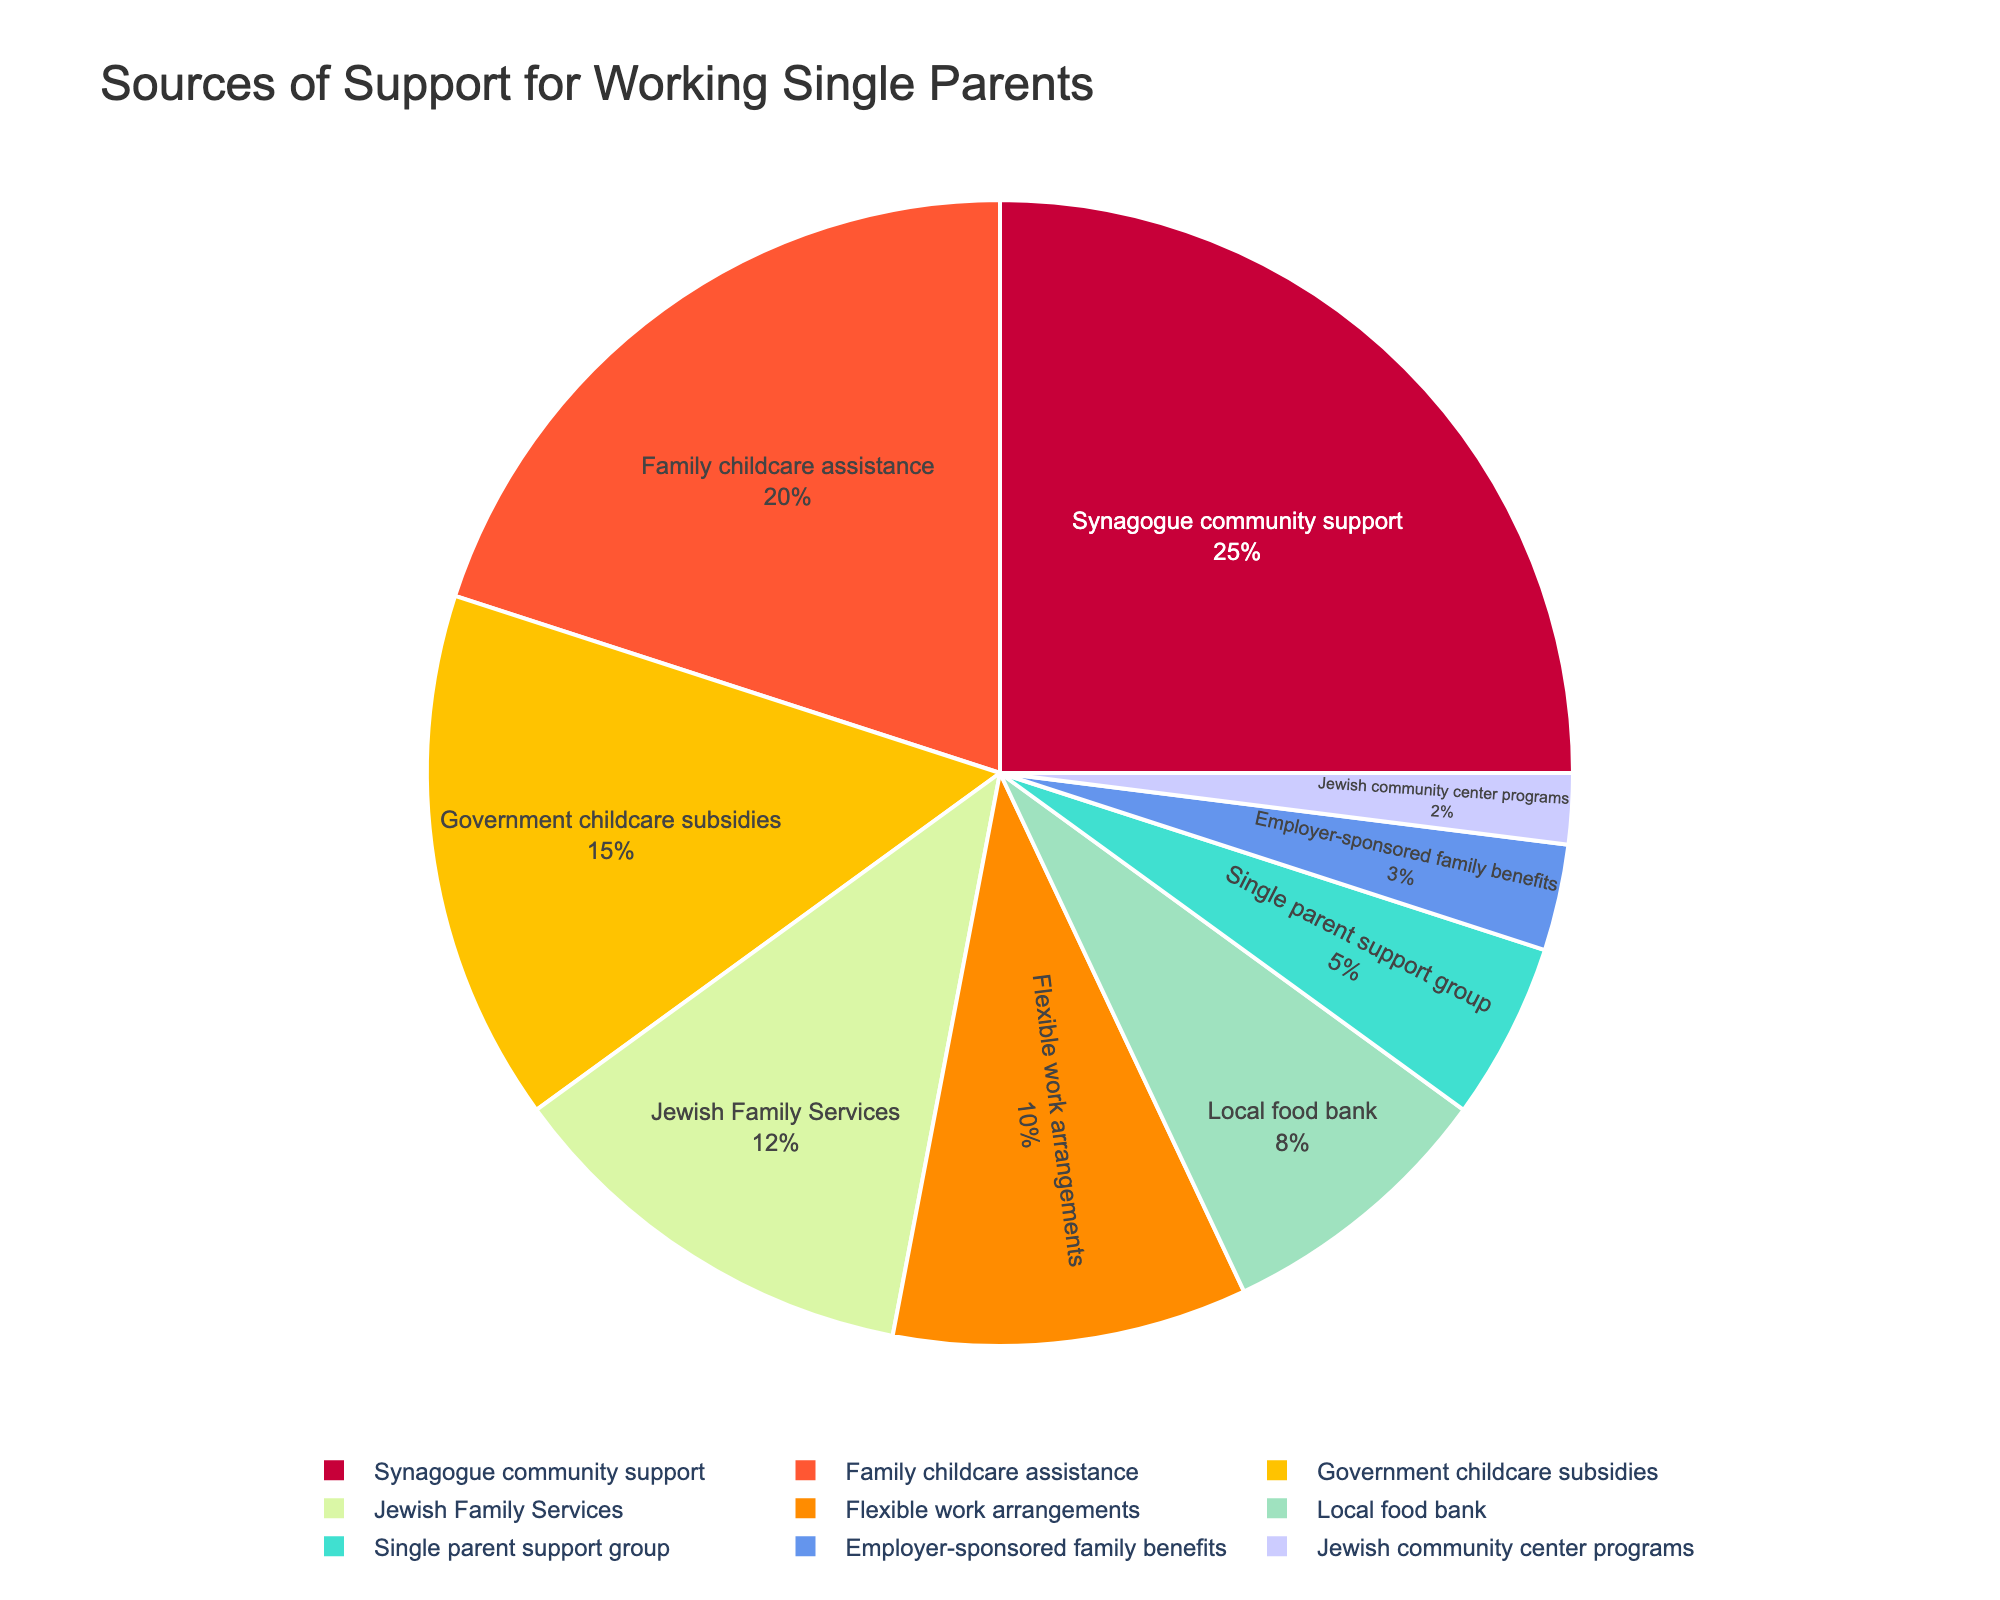Which source of support constitutes the largest portion of the pie chart? The largest portion can be identified by looking for the largest slice of the pie. Synagogue community support occupies the largest slice.
Answer: Synagogue community support What is the combined percentage of Family childcare assistance and Government childcare subsidies? To find the combined percentage, add the percentages of Family childcare assistance (20%) and Government childcare subsidies (15%). 20% + 15% = 35%.
Answer: 35% Which sources of support have a percentage that is less than 10%? To find this, identify all slices in the pie chart with percentages less than 10%. They are Local food bank (8%), Single parent support group (5%), Employer-sponsored family benefits (3%), and Jewish community center programs (2%).
Answer: Local food bank, Single parent support group, Employer-sponsored family benefits, Jewish community center programs By how much does the percentage of Synagogue community support exceed that of Jewish Family Services? Subtract the percentage of Jewish Family Services (12%) from Synagogue community support (25%). 25% - 12% = 13%.
Answer: 13% What is the average percentage of Flexible work arrangements, Local food bank, and Single parent support group? To compute the average, sum up the percentages of Flexible work arrangements (10%), Local food bank (8%), and Single parent support group (5%) and divide by 3. (10% + 8% + 5%) / 3 = 7.67%.
Answer: 7.67% Is the percentage of Flexible work arrangements greater than or less than the percentage of Family childcare assistance? Compare the percentages of Flexible work arrangements (10%) and Family childcare assistance (20%). 10% is less than 20%.
Answer: Less than Which source of support provides less than half the percentage of Synagogue community support? Synagogue community support is 25%, so we find which sources are less than half of 25%, i.e., less than 12.5%. They are Jewish Family Services (12%), Flexible work arrangements (10%), Local food bank (8%), Single parent support group (5%), Employer-sponsored family benefits (3%), and Jewish community center programs (2%).
Answer: Jewish Family Services, Flexible work arrangements, Local food bank, Single parent support group, Employer-sponsored family benefits, Jewish community center programs If Employer-sponsored family benefits were to increase by 2%, what would be the new percentage? Add 2% to the current percentage of Employer-sponsored family benefits (3%). 3% + 2% = 5%.
Answer: 5% Which segment has a color that looks greenish on the pie chart? Identify the segment associated with a greenish color. By the color palette, Local food bank appears to have a greenish color.
Answer: Local food bank 